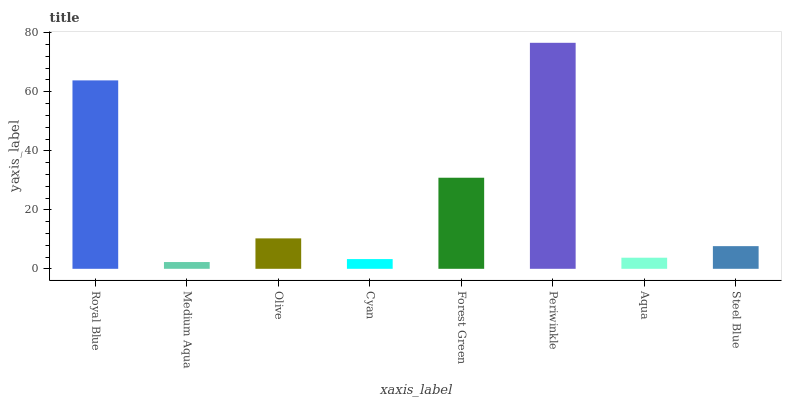Is Medium Aqua the minimum?
Answer yes or no. Yes. Is Periwinkle the maximum?
Answer yes or no. Yes. Is Olive the minimum?
Answer yes or no. No. Is Olive the maximum?
Answer yes or no. No. Is Olive greater than Medium Aqua?
Answer yes or no. Yes. Is Medium Aqua less than Olive?
Answer yes or no. Yes. Is Medium Aqua greater than Olive?
Answer yes or no. No. Is Olive less than Medium Aqua?
Answer yes or no. No. Is Olive the high median?
Answer yes or no. Yes. Is Steel Blue the low median?
Answer yes or no. Yes. Is Periwinkle the high median?
Answer yes or no. No. Is Medium Aqua the low median?
Answer yes or no. No. 